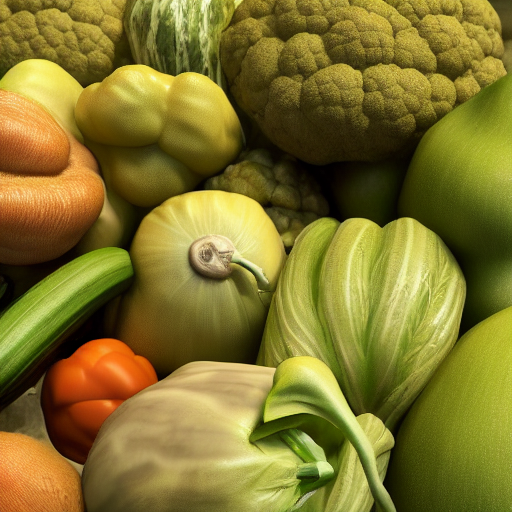What emotions does the color palette of the image evoke? The vibrant and warm hues of the vegetables convey a sense of abundance and vitality. The greens and oranges may evoke feelings of freshness and health, while the overall diversity in color suggests a harmonious coexistence within nature. 